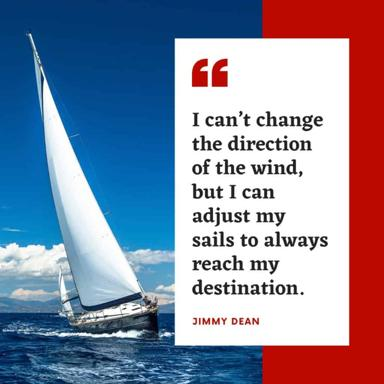What is the message of the quote in the image? The quote by Jimmy Dean, "I can't change the direction of the wind, but I can adjust my sails to always reach my destination," underscores the power of adaptability. It teaches us that while we may not have control over external conditions, we have the autonomy to alter our strategies or paths to overcome these challenges. The philosophy promotes resilience and proactive problem-solving as key tools for navigating life’s unpredictable landscapes. 